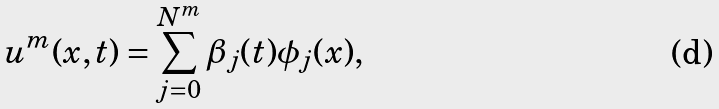Convert formula to latex. <formula><loc_0><loc_0><loc_500><loc_500>u ^ { m } ( x , t ) = \sum _ { j = 0 } ^ { N ^ { m } } \beta _ { j } ( t ) \phi _ { j } ( x ) ,</formula> 